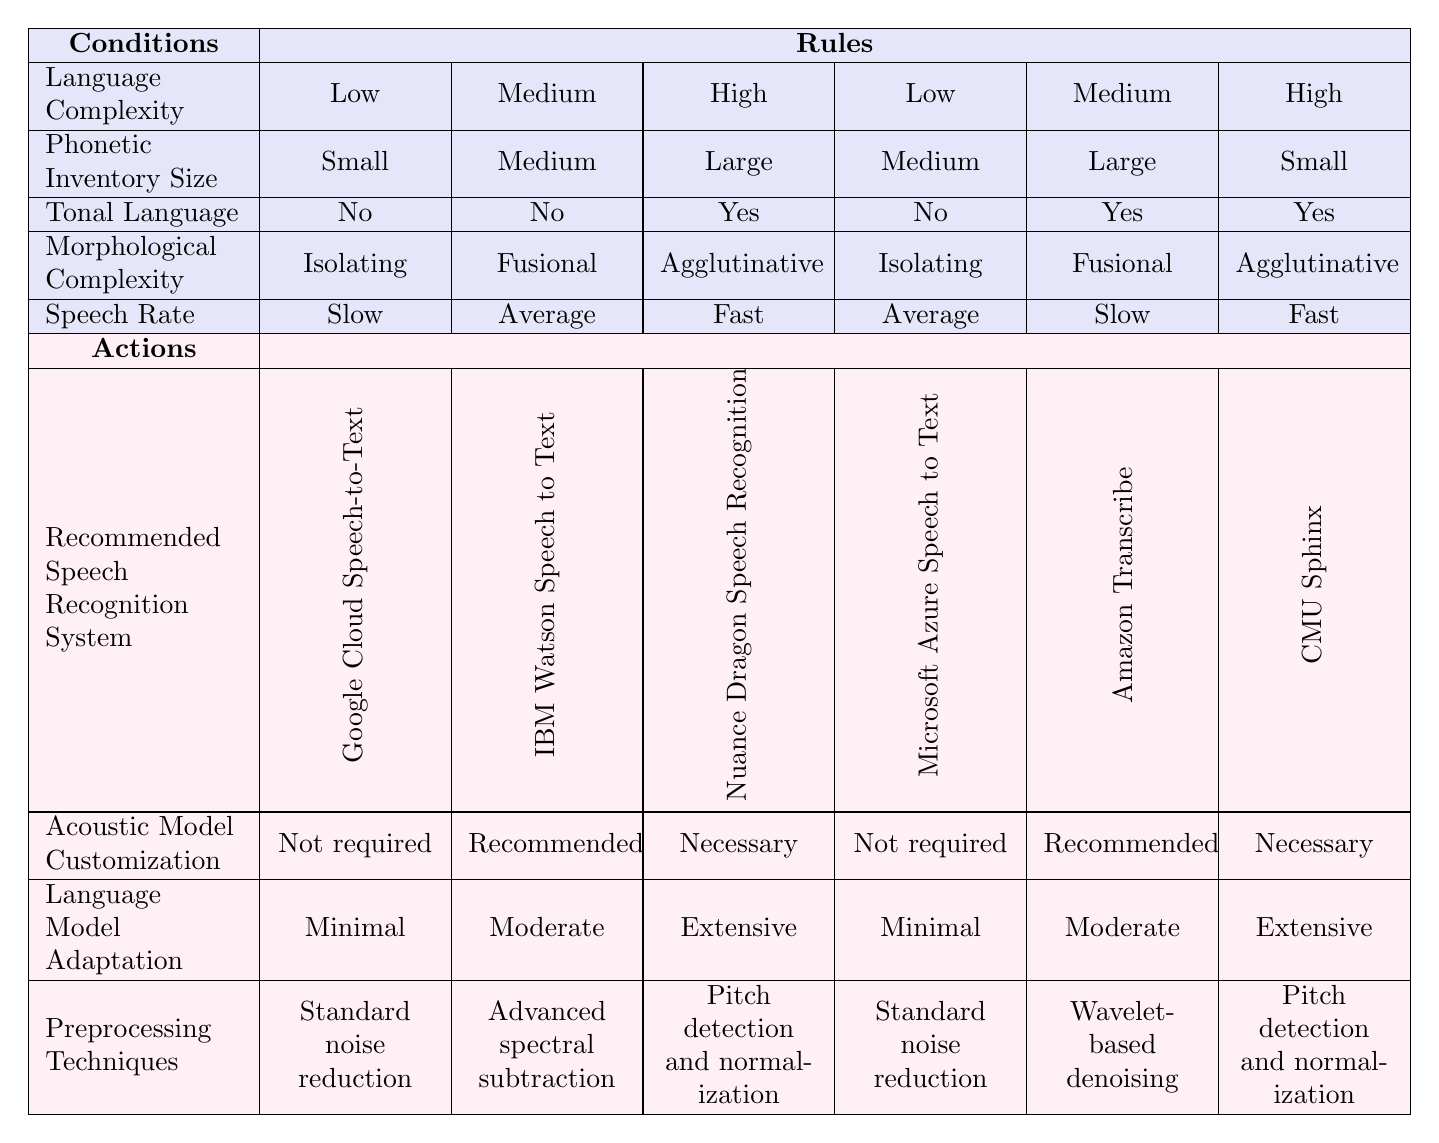What is the recommended speech recognition system for a low complexity language with a small phonetic inventory? Looking at the first rule in the table, the conditions state low complexity, small phonetic inventory, no tonal language, isolating morphology, and slow speech rate. The recommended system under these conditions is Google Cloud Speech-to-Text.
Answer: Google Cloud Speech-to-Text Which language complexity level is associated with the need for extensive language model adaptation? By examining the rules, we can see that extensive language model adaptation is required for a high complexity language. Specifically, it aligns with the rule for a language with a large phonetic inventory and tonal language when the speech rate is fast.
Answer: High Is acoustic model customization necessary for high complexity tonal languages with a large phonetic inventory? The third rule specifies that for high complexity, large phonetic inventory, tonal languages, and fast speech rate, acoustic model customization is necessary. Therefore, the answer is yes.
Answer: Yes What preprocessing technique is recommended for medium complexity languages with large phonetic inventories and slow speech rates? Referring to the rule for medium complexity, large phonetic inventories, tonal languages, and slow speech rate, the recommended preprocessing technique is wavelet-based denoising.
Answer: Wavelet-based denoising How many different recommended speech recognition systems are suggested for low complexity languages? Investigating the table reveals two distinct rows pertaining to low complexity languages, suggesting Google Cloud Speech-to-Text and Microsoft Azure Speech to Text as the systems recommended. Thus, there are 2 systems.
Answer: 2 If you combine the recommendations for language model adaptation for low complexity languages, what is the total? The table indicates minimal language model adaptation required for both low complexity rows. Therefore, since both adaptations are minimal, the total is minimal for low complexity languages.
Answer: Minimal Which morphological complexity is required for the highest complexity level, and what is its associated speech rate? The rules state that for high complexity a language is agrlutinative and the speech rate must be fast. Hence, the required morphological complexity is agglutinative with a fast speech rate.
Answer: Agglutinative and Fast Are standard noise reduction techniques used in the systems recommended for medium complexity languages? From the evaluation of rules two and four, the recommended systems for medium complexity languages with medium phonetic inventories use advanced spectral subtraction and standard noise reduction respectively. So, standard noise reduction is used in one scenario and not the other.
Answer: Yes What acoustic model customization is associated with the recommended speech recognition system for a high complexity, large phonetic inventory, tonal language, and fast speech rate? Referring the third rule, for these conditions, it specifies that acoustic model customization is necessary when using Nuance Dragon Speech Recognition.
Answer: Necessary 